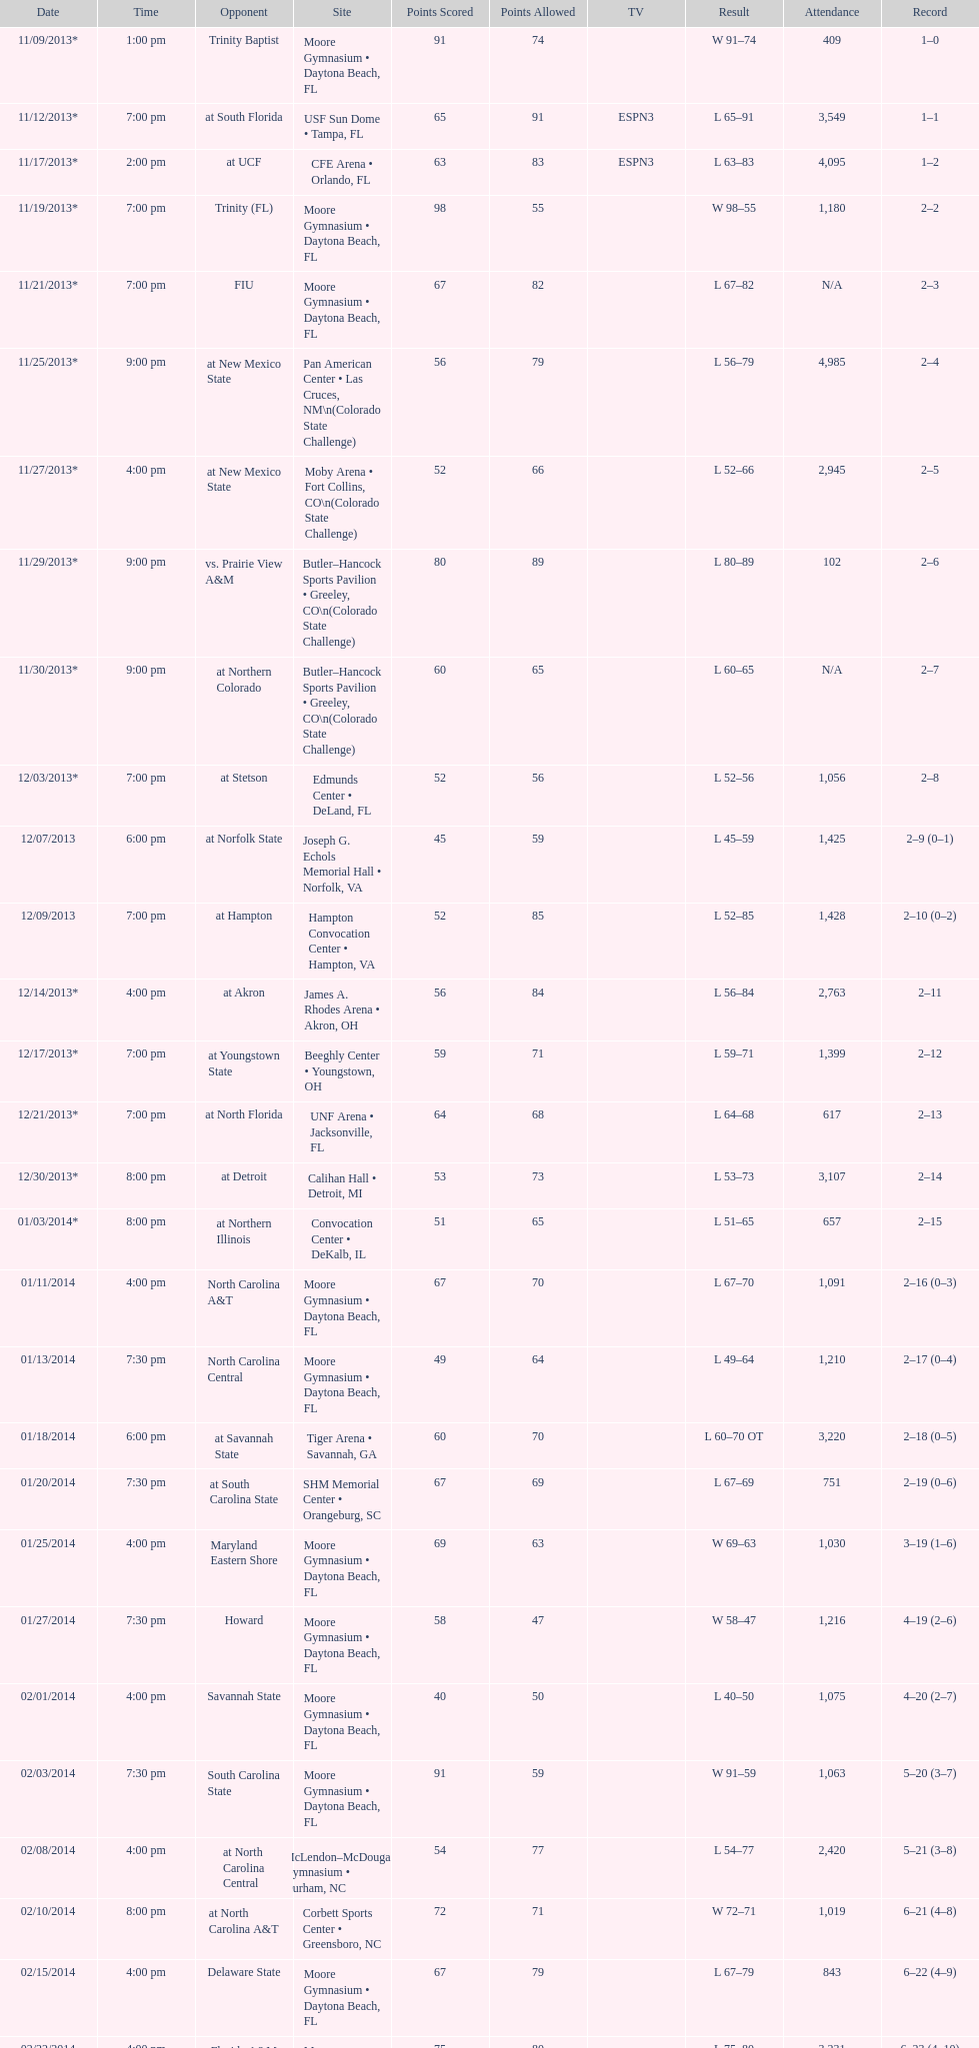How many games did the wildcats play in daytona beach, fl? 11. 